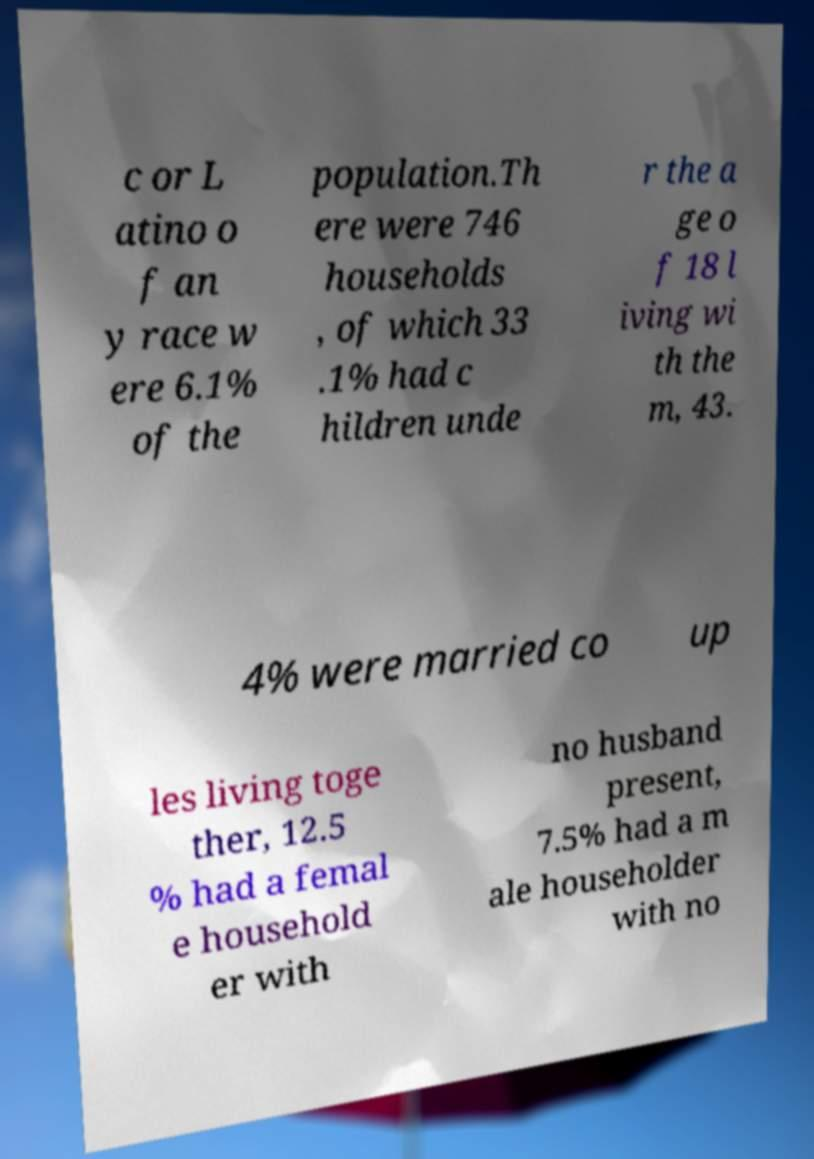Could you assist in decoding the text presented in this image and type it out clearly? c or L atino o f an y race w ere 6.1% of the population.Th ere were 746 households , of which 33 .1% had c hildren unde r the a ge o f 18 l iving wi th the m, 43. 4% were married co up les living toge ther, 12.5 % had a femal e household er with no husband present, 7.5% had a m ale householder with no 